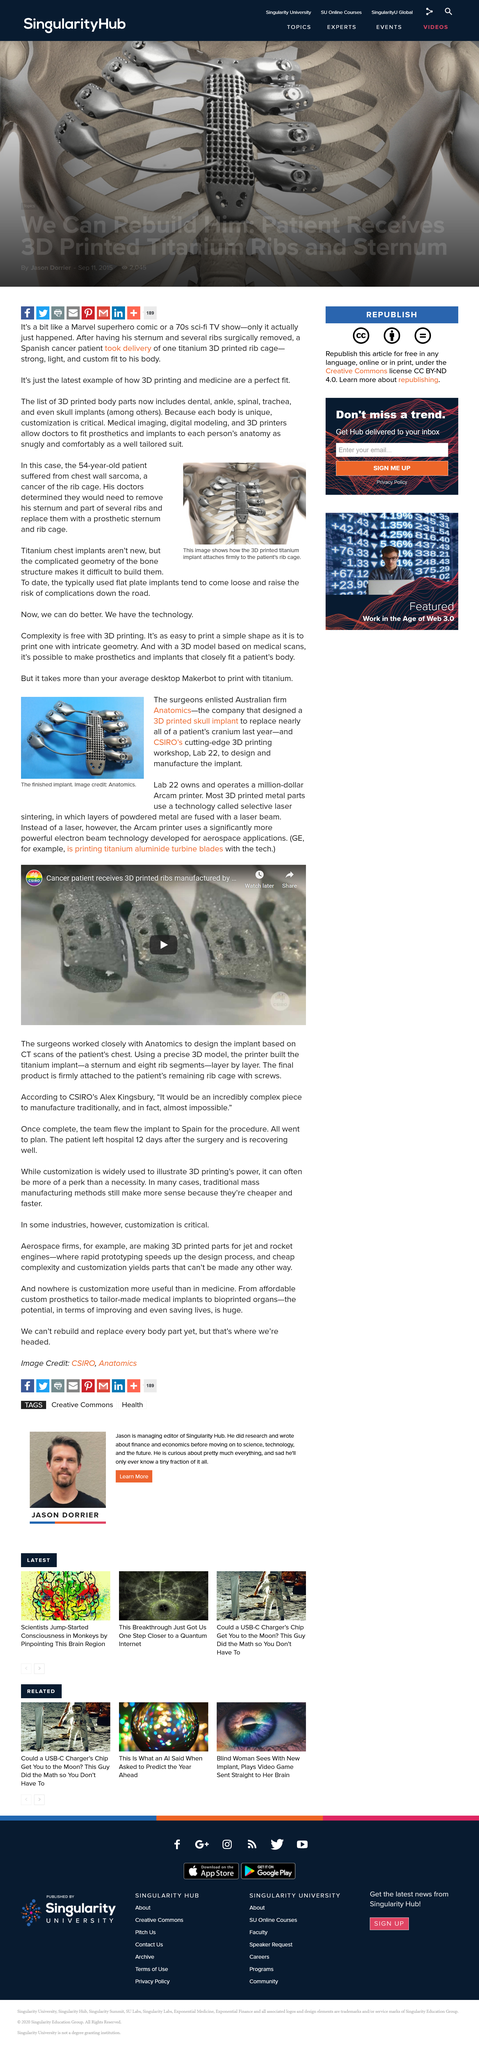Highlight a few significant elements in this photo. It is unknown who owns the Arcam printer. Lab 22 may be the owner of the Arcam printer. It is a commonly known fact that chest implants are typically made from titanium. The image depicts a finished dental implant. Two significant challenges exist in the use of chest implants, due to the complex geometry of the bone structure, and the tendency of the implants to become loose, leading to additional complications. I have determined that the name of the Australian company involved in the production of a 3D printed skull implant is Anatomics. 